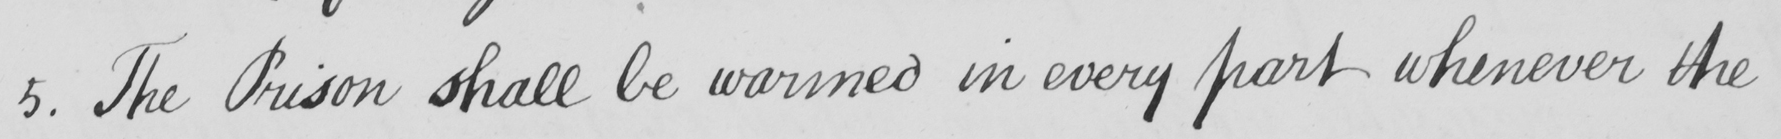Can you read and transcribe this handwriting? 5 . The Prison shall be warmed in every part whenever the 